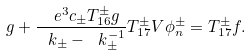Convert formula to latex. <formula><loc_0><loc_0><loc_500><loc_500>g + \frac { \ e ^ { 3 } c _ { \pm } T _ { 1 6 } ^ { \pm } g } { \ k _ { \pm } - \ k _ { \pm } ^ { - 1 } } T _ { 1 7 } ^ { \pm } V \phi _ { n } ^ { \pm } = T _ { 1 7 } ^ { \pm } f .</formula> 